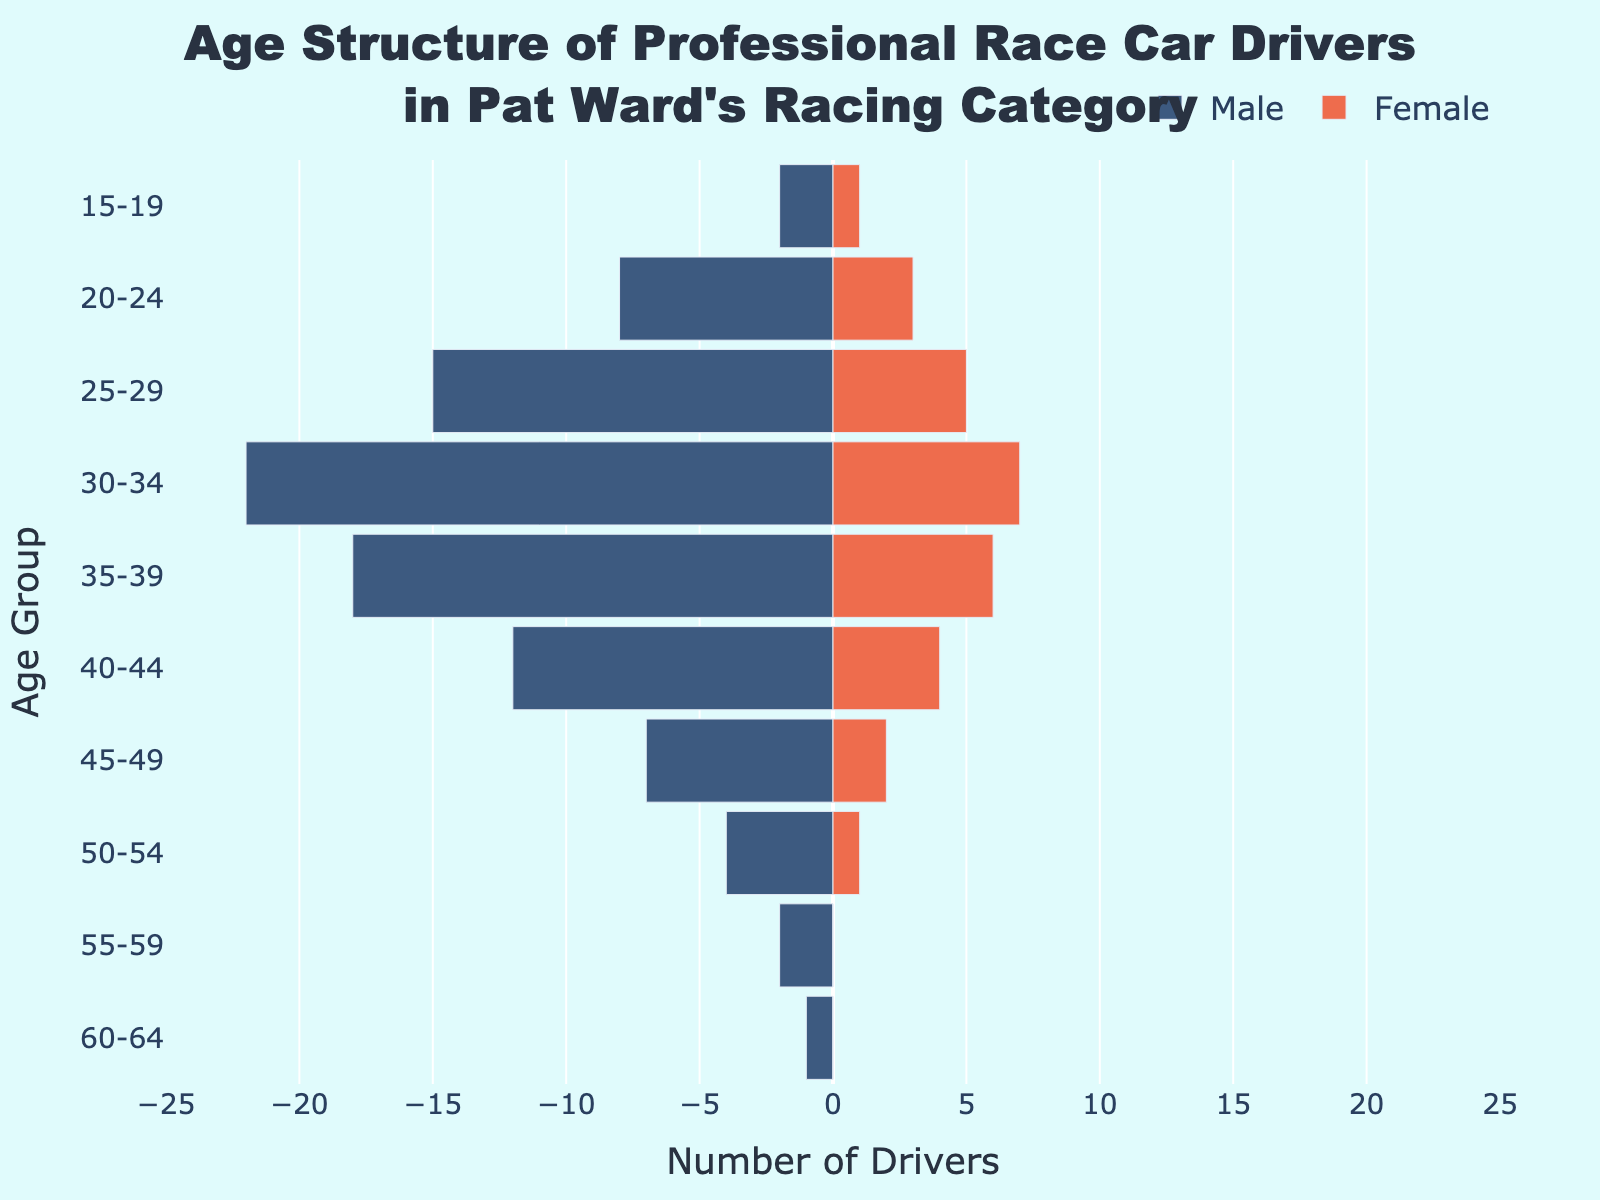What is the title of the figure? The title of the figure is located at the top and states: "Age Structure of Professional Race Car Drivers in Pat Ward's Racing Category." This provides context about the data being visualized.
Answer: Age Structure of Professional Race Car Drivers in Pat Ward's Racing Category How many female drivers are in the 25-29 age group? Look at the right side of the pyramid where the female bars are located and find the bar corresponding to the 25-29 age group. The length of the bar indicates there are 5 female drivers in this age group.
Answer: 5 Which gender has more drivers in the 35-39 age group? Compare the lengths of the bars for males (left) and females (right) in the 35-39 age group. The male bar is longer, indicating more male drivers.
Answer: Male What is the total number of male drivers? Add the number of male drivers across all age groups: 2 + 8 +12 + 22 + 18 + 12 + 7 + 4 + 2 + 1 = 88.
Answer: 88 What age group has the highest number of male drivers? Examine the left side of the pyramid to see which age group has the longest bar. The 30-34 age group has the longest male bar, indicating the highest number of male drivers.
Answer: 30-34 How does the distribution of female drivers compare between the 20-24 and 50-54 age groups? Compare the lengths of the bars for female drivers in the 20-24 and 50-54 age groups. The bar for 20-24 is significantly longer, indicating many more female drivers in that age group.
Answer: More female drivers in 20-24 What is the combined number of drivers (both genders) in the 40-44 age group? Add the number of male and female drivers in the 40-44 age group: 12 (male) + 4 (female) = 16.
Answer: 16 Are there any age groups with no female drivers? Check the right side of the pyramid for any age groups with zero-length bars. The 55-59 and 60-64 age groups have no female bars, indicating no female drivers.
Answer: Yes, 55-59 and 60-64 In which age group is the difference between the number of male and female drivers the smallest? Calculate the absolute difference in each age group and identify the smallest. For example, 15-19 (1), 20-24 (5), 25-29 (10), 30-34 (15), 35-39 (12), 40-44 (8), 45-49 (5), 50-54 (3), 55-59 (2), 60-64 (1). The smallest difference is 15-19 and 60-64, both having a difference of 1.
Answer: 15-19 Which age group has the same number of male drivers as female drivers in another group? Observe the bars and note which age groups have matching numbers across genders. 60-64 males (1 driver) matches 15-19 females (1 driver).
Answer: 60-64 males, 15-19 females 